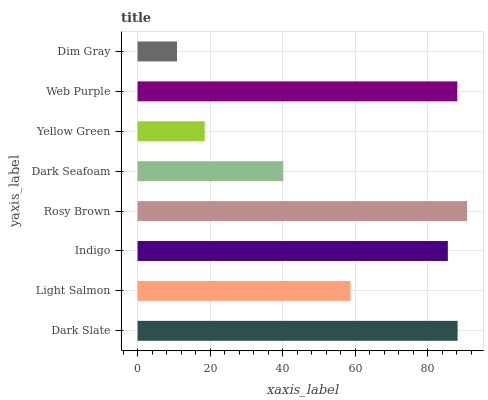Is Dim Gray the minimum?
Answer yes or no. Yes. Is Rosy Brown the maximum?
Answer yes or no. Yes. Is Light Salmon the minimum?
Answer yes or no. No. Is Light Salmon the maximum?
Answer yes or no. No. Is Dark Slate greater than Light Salmon?
Answer yes or no. Yes. Is Light Salmon less than Dark Slate?
Answer yes or no. Yes. Is Light Salmon greater than Dark Slate?
Answer yes or no. No. Is Dark Slate less than Light Salmon?
Answer yes or no. No. Is Indigo the high median?
Answer yes or no. Yes. Is Light Salmon the low median?
Answer yes or no. Yes. Is Dim Gray the high median?
Answer yes or no. No. Is Indigo the low median?
Answer yes or no. No. 